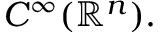Convert formula to latex. <formula><loc_0><loc_0><loc_500><loc_500>C ^ { \infty } ( \mathbb { R } ^ { n } ) .</formula> 